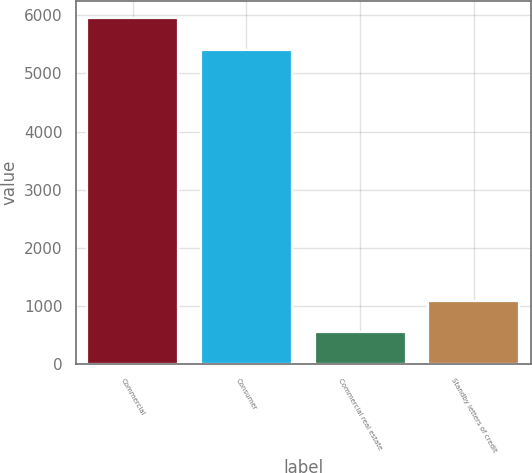Convert chart to OTSL. <chart><loc_0><loc_0><loc_500><loc_500><bar_chart><fcel>Commercial<fcel>Consumer<fcel>Commercial real estate<fcel>Standby letters of credit<nl><fcel>5944.7<fcel>5406<fcel>546<fcel>1084.7<nl></chart> 